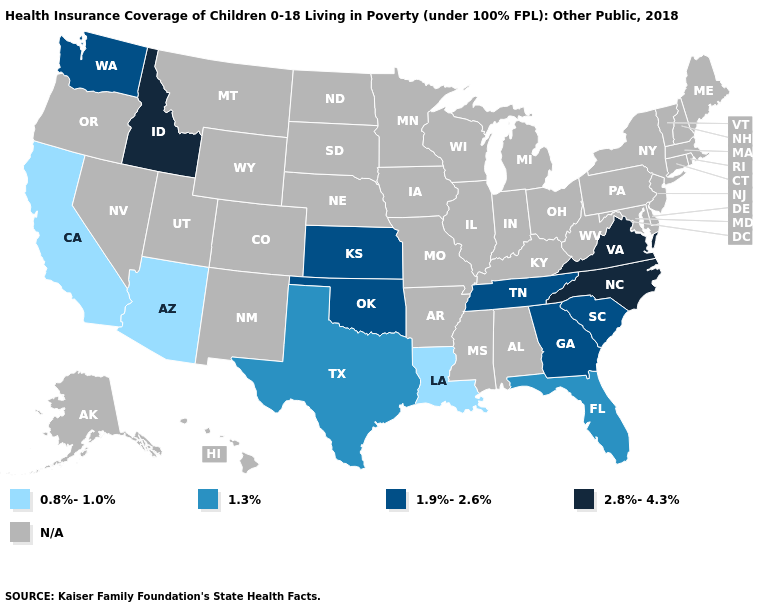Does the first symbol in the legend represent the smallest category?
Be succinct. Yes. Name the states that have a value in the range 1.3%?
Answer briefly. Florida, Texas. Name the states that have a value in the range 2.8%-4.3%?
Keep it brief. Idaho, North Carolina, Virginia. Which states have the lowest value in the USA?
Give a very brief answer. Arizona, California, Louisiana. What is the value of Nevada?
Concise answer only. N/A. What is the lowest value in the USA?
Write a very short answer. 0.8%-1.0%. Which states have the lowest value in the USA?
Give a very brief answer. Arizona, California, Louisiana. Is the legend a continuous bar?
Quick response, please. No. Name the states that have a value in the range 1.3%?
Give a very brief answer. Florida, Texas. What is the value of Delaware?
Write a very short answer. N/A. Does North Carolina have the lowest value in the South?
Answer briefly. No. Among the states that border Georgia , does North Carolina have the highest value?
Short answer required. Yes. 